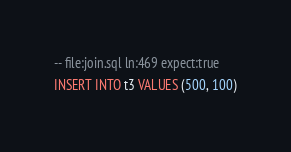<code> <loc_0><loc_0><loc_500><loc_500><_SQL_>-- file:join.sql ln:469 expect:true
INSERT INTO t3 VALUES (500, 100)
</code> 